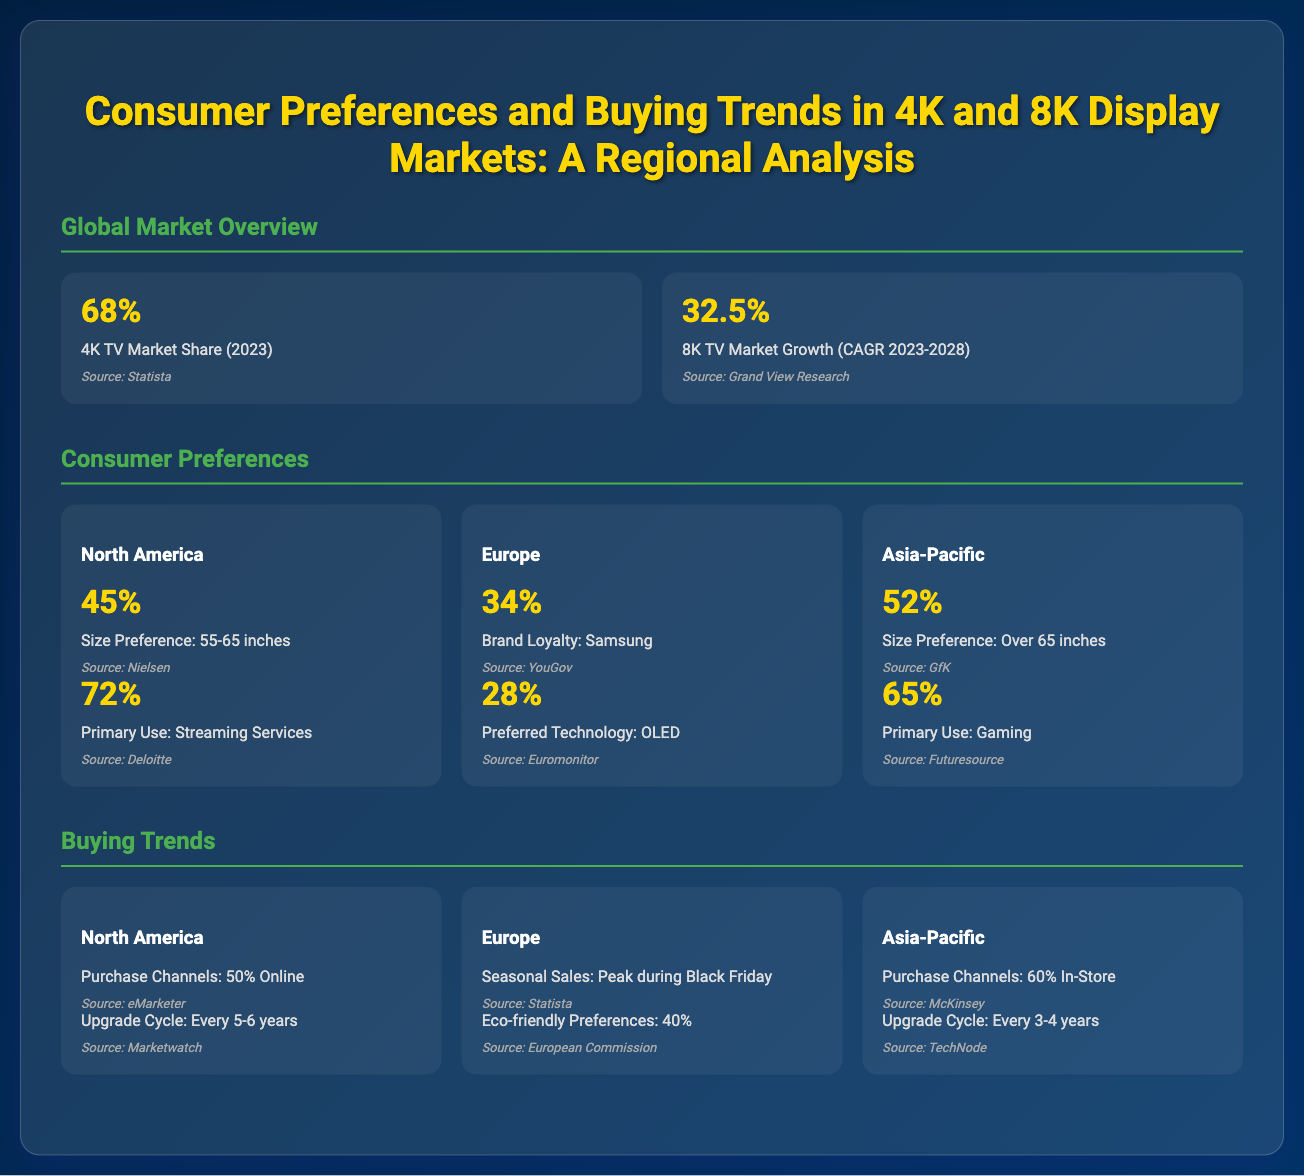what is the 4K TV market share in 2023? The document states that the 4K TV market share in 2023 is 68%.
Answer: 68% what is the CAGR for 8K TV market growth from 2023 to 2028? The document indicates that the compound annual growth rate (CAGR) for the 8K TV market from 2023 to 2028 is 32.5%.
Answer: 32.5% what is the primary use of TVs in North America? According to the document, the primary use of TVs in North America is 72% for streaming services.
Answer: Streaming Services what is the preferred technology in Europe? The document mentions that the preferred technology in Europe is OLED, with 28% stating this preference.
Answer: OLED what percentage of consumers in Asia-Pacific prefer a TV size over 65 inches? The document indicates that 52% of consumers in the Asia-Pacific region prefer a TV size over 65 inches.
Answer: 52% which region has the highest percentage for purchase channels being in-store? The document reveals that the Asia-Pacific region has the highest percentage for purchase channels being in-store at 60%.
Answer: Asia-Pacific what season experiences peak seasonal sales in Europe? The document states that peak seasonal sales in Europe occur during Black Friday.
Answer: Black Friday what is the upgrade cycle for TVs in North America? The document specifies that the upgrade cycle for TVs in North America is every 5-6 years.
Answer: Every 5-6 years which region has a higher percentage of brand loyalty towards Samsung? The document indicates that Europe has a higher percentage of brand loyalty towards Samsung at 34%.
Answer: Europe 